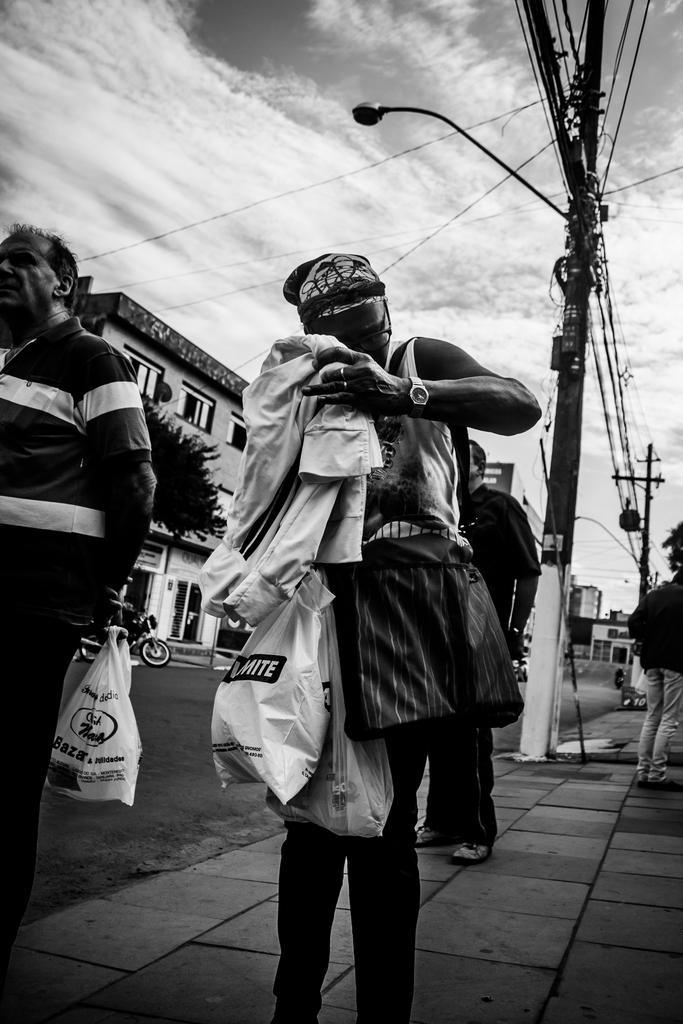Can you describe this image briefly? This is the picture of a person who is wearing the bag and holding some covers and inside there is an other person who is holding the covers and also we can see some buildings, poles which has some wires and the other person to the side. 